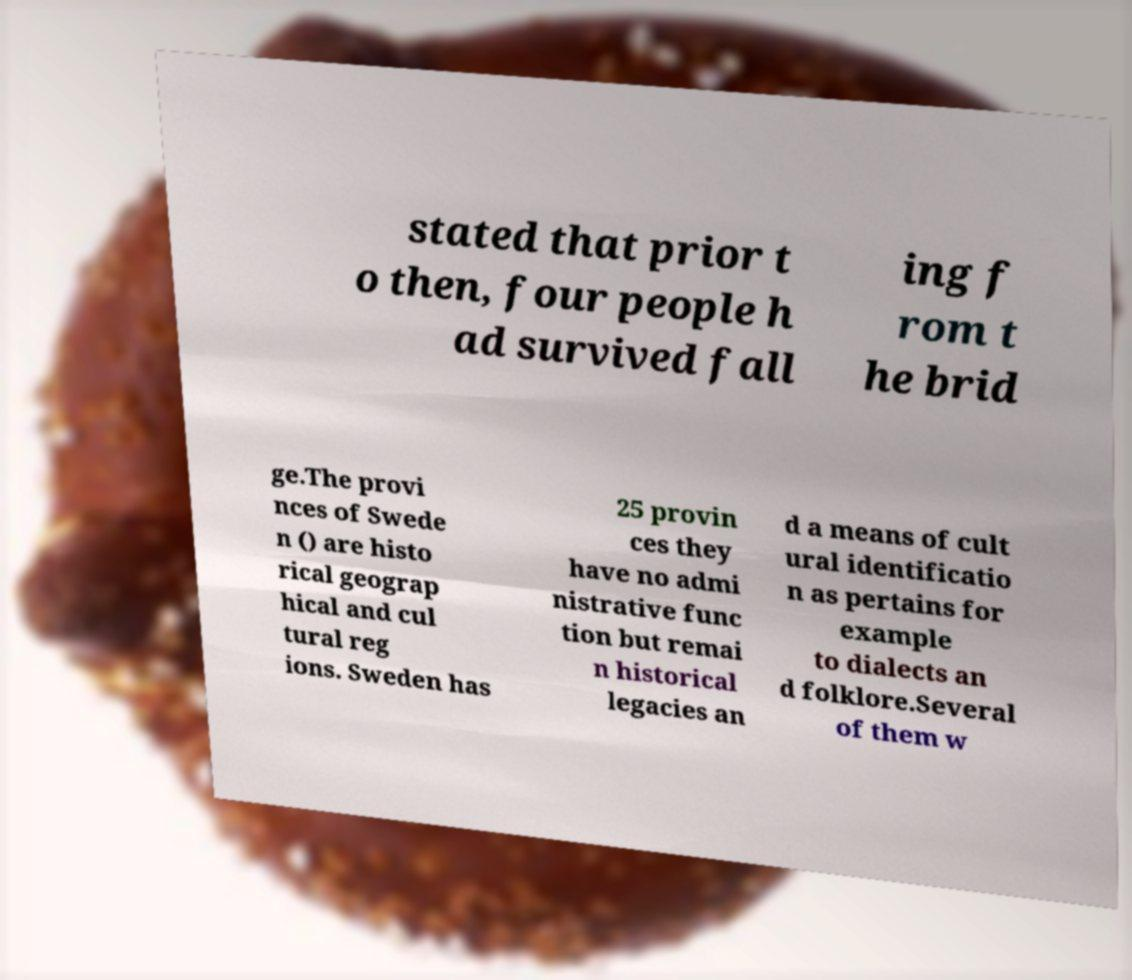Please read and relay the text visible in this image. What does it say? stated that prior t o then, four people h ad survived fall ing f rom t he brid ge.The provi nces of Swede n () are histo rical geograp hical and cul tural reg ions. Sweden has 25 provin ces they have no admi nistrative func tion but remai n historical legacies an d a means of cult ural identificatio n as pertains for example to dialects an d folklore.Several of them w 